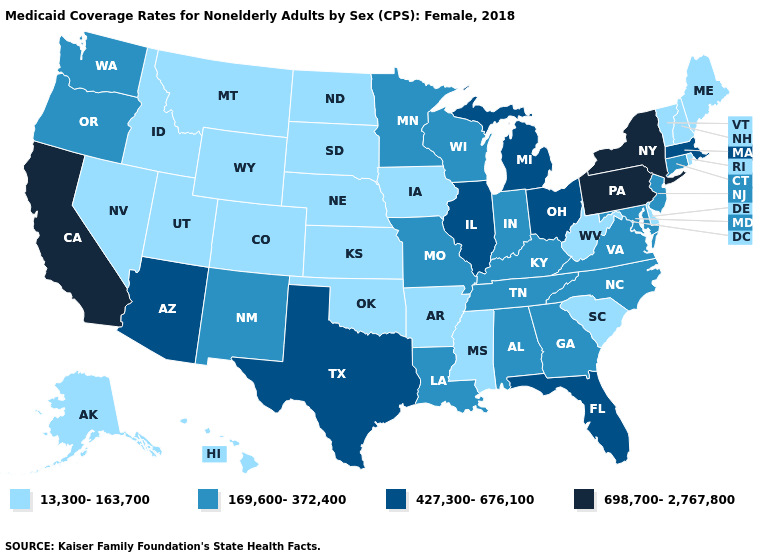What is the value of Utah?
Answer briefly. 13,300-163,700. What is the value of Florida?
Quick response, please. 427,300-676,100. Does Idaho have a lower value than Vermont?
Keep it brief. No. Name the states that have a value in the range 169,600-372,400?
Write a very short answer. Alabama, Connecticut, Georgia, Indiana, Kentucky, Louisiana, Maryland, Minnesota, Missouri, New Jersey, New Mexico, North Carolina, Oregon, Tennessee, Virginia, Washington, Wisconsin. Name the states that have a value in the range 169,600-372,400?
Write a very short answer. Alabama, Connecticut, Georgia, Indiana, Kentucky, Louisiana, Maryland, Minnesota, Missouri, New Jersey, New Mexico, North Carolina, Oregon, Tennessee, Virginia, Washington, Wisconsin. Name the states that have a value in the range 427,300-676,100?
Keep it brief. Arizona, Florida, Illinois, Massachusetts, Michigan, Ohio, Texas. Which states have the lowest value in the USA?
Answer briefly. Alaska, Arkansas, Colorado, Delaware, Hawaii, Idaho, Iowa, Kansas, Maine, Mississippi, Montana, Nebraska, Nevada, New Hampshire, North Dakota, Oklahoma, Rhode Island, South Carolina, South Dakota, Utah, Vermont, West Virginia, Wyoming. Which states have the highest value in the USA?
Concise answer only. California, New York, Pennsylvania. Among the states that border California , which have the highest value?
Answer briefly. Arizona. What is the lowest value in the South?
Keep it brief. 13,300-163,700. What is the value of New York?
Give a very brief answer. 698,700-2,767,800. Name the states that have a value in the range 169,600-372,400?
Quick response, please. Alabama, Connecticut, Georgia, Indiana, Kentucky, Louisiana, Maryland, Minnesota, Missouri, New Jersey, New Mexico, North Carolina, Oregon, Tennessee, Virginia, Washington, Wisconsin. What is the value of Kentucky?
Give a very brief answer. 169,600-372,400. Does the map have missing data?
Short answer required. No. What is the lowest value in states that border New York?
Keep it brief. 13,300-163,700. 